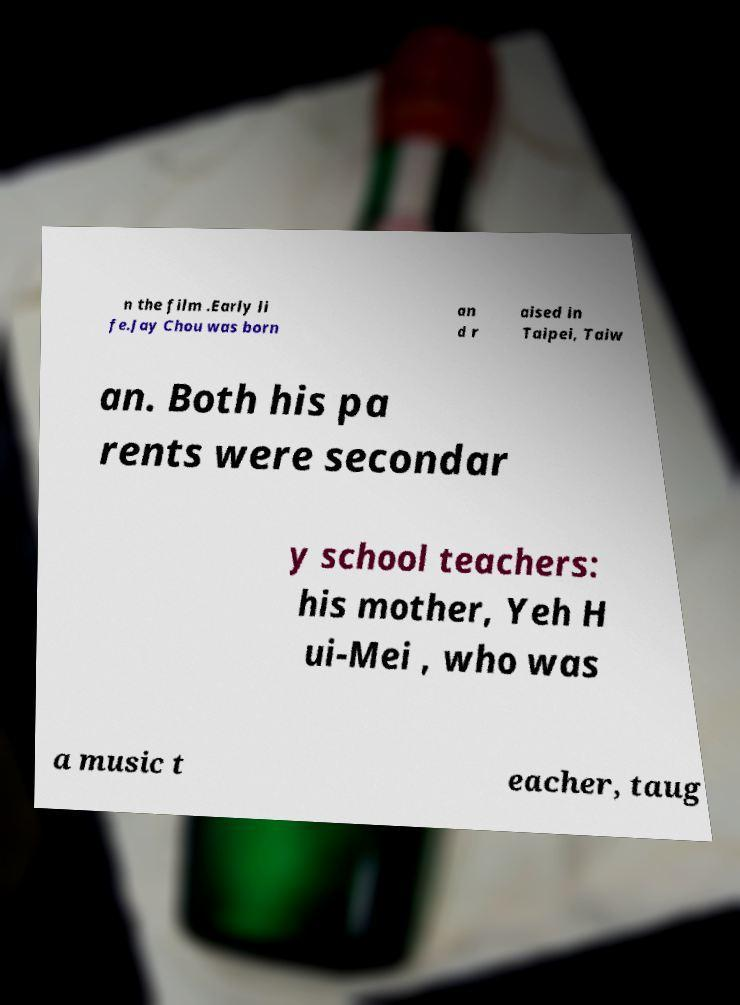Can you read and provide the text displayed in the image?This photo seems to have some interesting text. Can you extract and type it out for me? n the film .Early li fe.Jay Chou was born an d r aised in Taipei, Taiw an. Both his pa rents were secondar y school teachers: his mother, Yeh H ui-Mei , who was a music t eacher, taug 